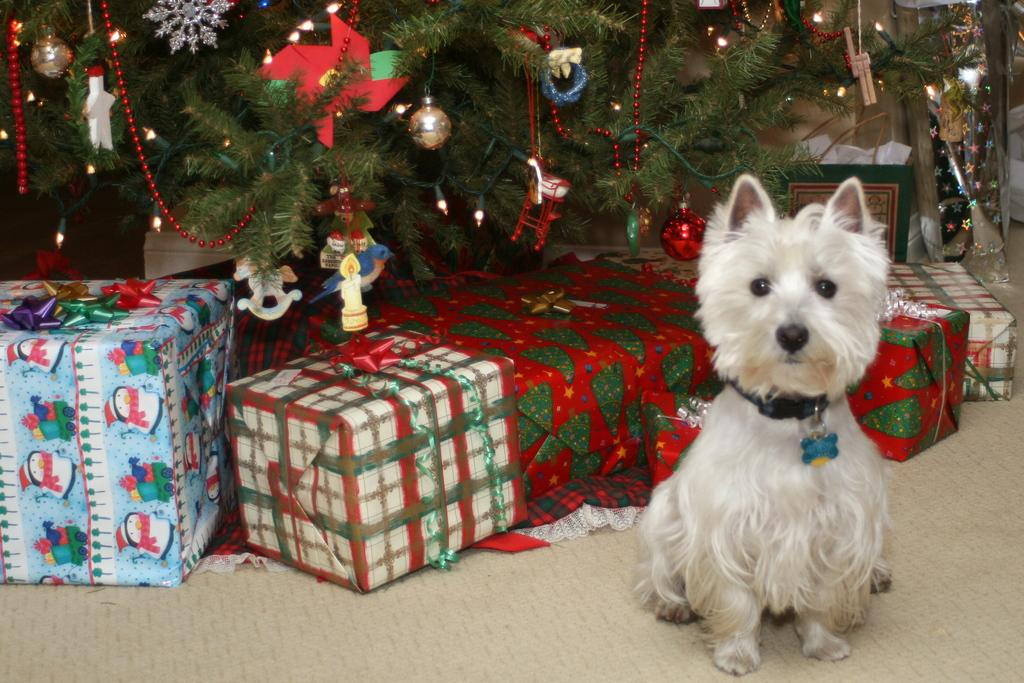What type of tree is in the image? There is a Christmas tree in the image. What decorations can be seen on the tree? Balls, toys, and other objects are on the tree. Are there any gifts visible in the image? Yes, there are gifts in the image. What can be said about the colors of the gifts? The gifts are in different colors. Is there any animal present in the image? Yes, there is a white-colored dog in front of the tree. What type of scent can be detected from the image? There is no information about a scent in the image, so it cannot be determined. --- Facts: 1. There is a person holding a book in the image. 2. The book has a blue cover. 3. The person is sitting on a chair. 4. There is a table next to the chair. 5. There is a lamp on the table. Absurd Topics: parrot, ocean, bicycle Conversation: What is the person in the image holding? The person is holding a book in the image. What color is the book's cover? The book has a blue cover. Where is the person sitting? The person is sitting on a chair. What is located next to the chair? There is a table next to the chair. What object is on the table? There is a lamp on the table. Reasoning: Let's think step by step in order to produce the conversation. We start by identifying the main subject in the image, which is the person holding a book. Then, we expand the conversation to include details about the book, the person's location, and the objects around them. Each question is designed to elicit a specific detail about the image that is known from the provided facts. Absurd Question/Answer: Can you see a parrot sitting on the person's shoulder in the image? No, there is no parrot present in the image. 